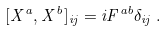<formula> <loc_0><loc_0><loc_500><loc_500>[ X ^ { a } , X ^ { b } ] _ { i j } = i F ^ { a b } \delta _ { i j } \, .</formula> 